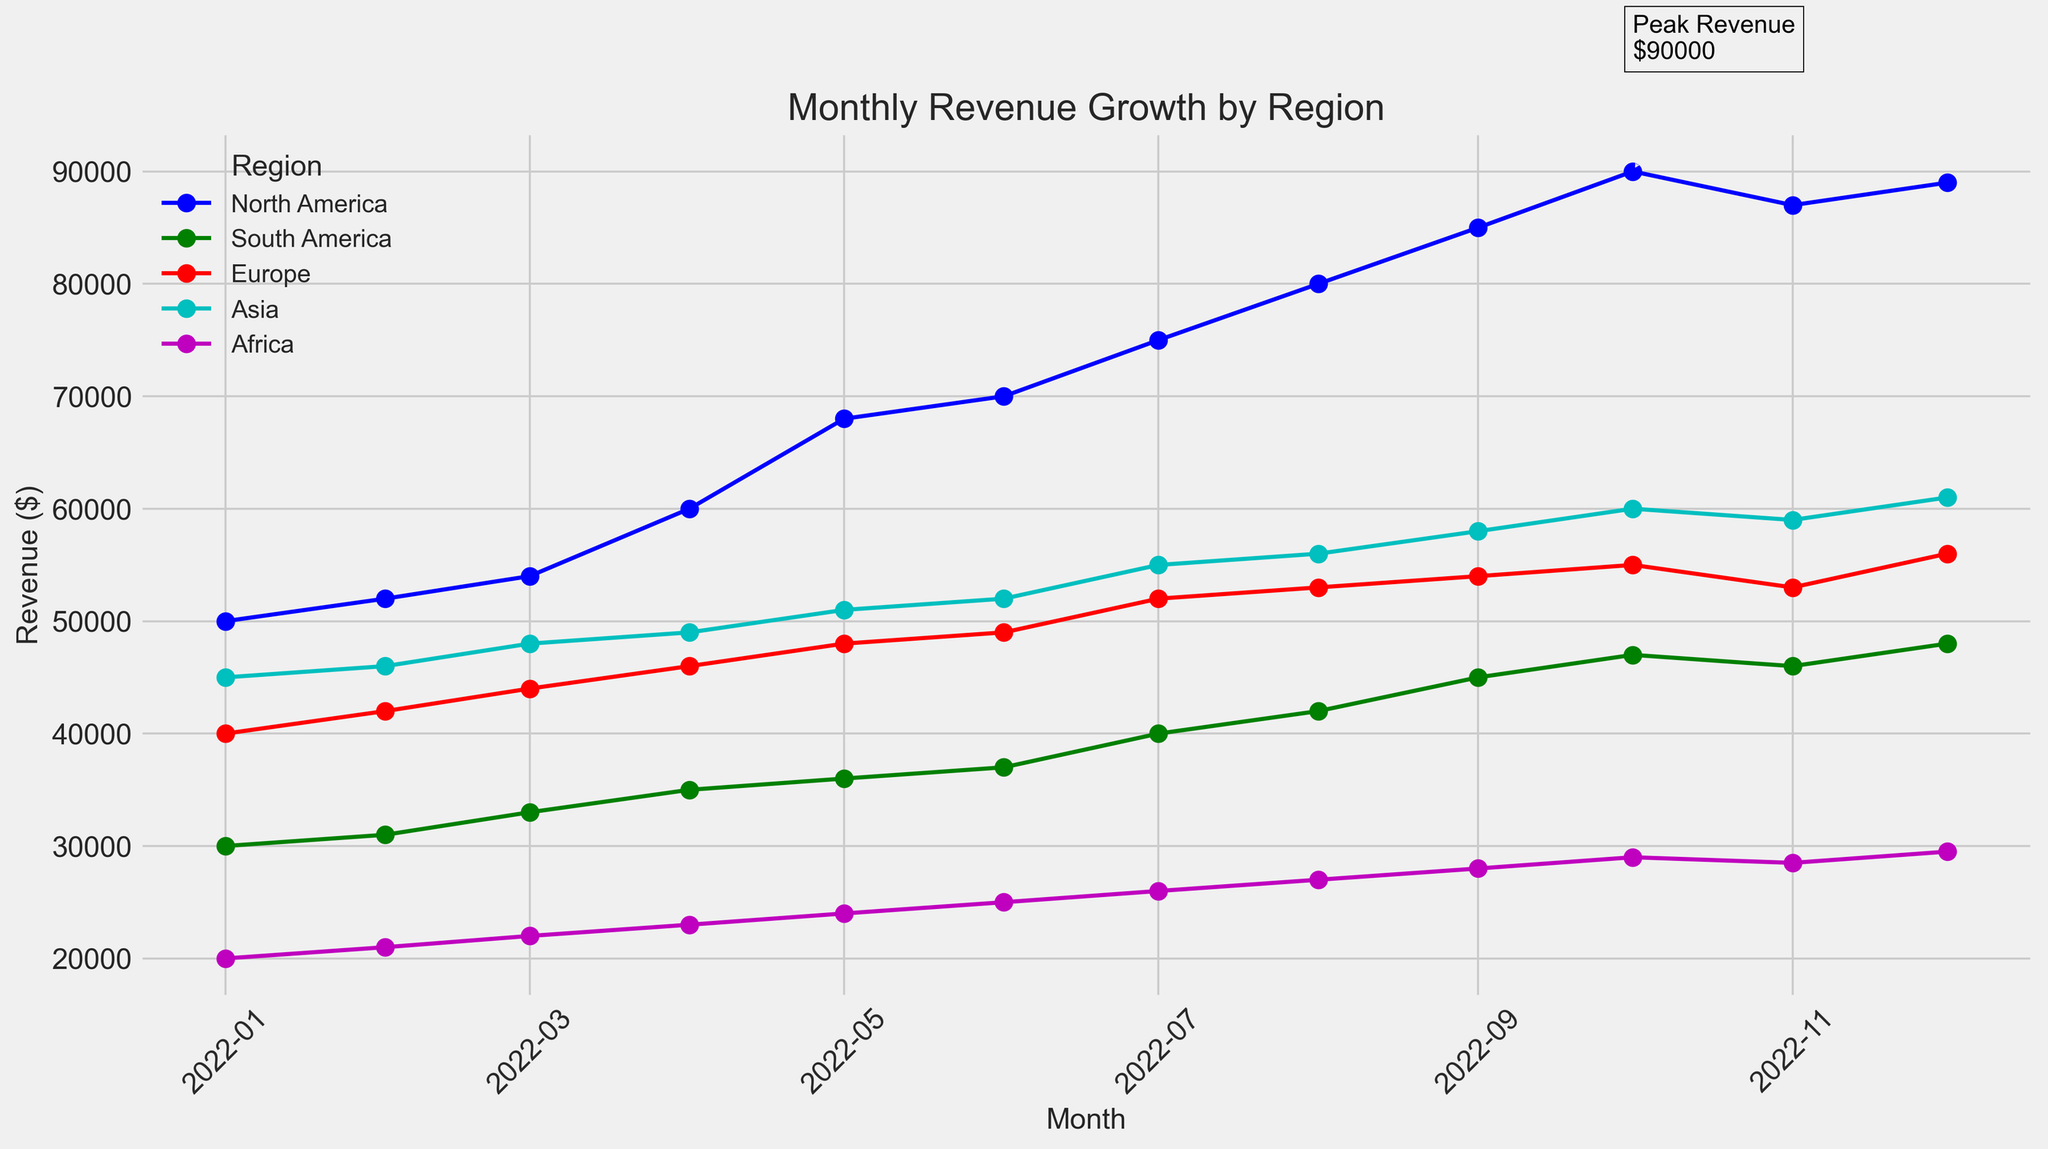Which region experienced the highest peak revenue, and in what month did it occur? The annotation on the chart indicates the peak revenue instance. By identifying this annotation, we can see that North America had the highest peak revenue, and it occurred in October 2022.
Answer: North America, October 2022 How does the revenue growth trend for North America compare to Europe over the year? Observing the slopes of the lines for North America and Europe, the North American revenue increases more steeply than Europe’s. North America had a consistent increase with a sharp rise around mid-year, while Europe’s growth is more gradual and steadier.
Answer: North America grew faster What was the peak revenue for each region? By identifying the highest points on each line, North America's peak was $90,000; South America's peak was $48,000; Europe's peak was $56,000; Asia's peak was $61,000; and Africa's peak was $29,500.
Answer: North America: $90,000, South America: $48,000, Europe: $56,000, Asia: $61,000, Africa: $29,500 Which regions experienced a decline in revenue in November 2022? Looking for revenue drops, North America and Asia experienced declines, where North America's revenue dropped from $90,000 to $87,000, and Asia’s revenue dropped from $60,000 to $59,000.
Answer: North America and Asia In which month did the revenue for South America first exceed $40,000? Following South America's trend line, the revenue first exceeds $40,000 in July 2022, where it reaches $40,000.
Answer: July 2022 How much did the revenue for North America increase from January to October 2022? The revenue for North America in January 2022 was $50,000, and in October 2022, it was $90,000. The increase is calculated as $90,000 - $50,000 = $40,000.
Answer: $40,000 Between March and August 2022, which region had the highest average revenue? Summing the revenues for each region from March to August 2022 and then finding the average: North America is ($54,000 + $60,000 + $68,000 + $70,000 + $75,000 + $80,000) / 6 = $67,833.33, South America is ($33,000 + $35,000 + $36,000 + $37,000 + $40,000 + $42,000) / 6 = $37,166.67, Europe is ($44,000 + $46,000 + $48,000 + $49,000 + $52,000 + $53,000) / 6 = $48,666.67, Asia is ($48,000 + $49,000 + $51,000 + $52,000 + $55,000 + $56,000) / 6 = $51,833.33, and Africa is ($22,000 + $23,000 + $24,000 + $25,000 + $26,000 + $27,000) / 6 = $24,500. North America had the highest average revenue.
Answer: North America What was the revenue for Europe in June 2022, and how did it change in the following month? Europe's revenue in June 2022 was $49,000. In July 2022, it increased to $52,000, resulting in a change of $3,000.
Answer: June: $49,000, Change: $3,000 Compare the revenue trend of Africa and South America. Which region experienced a more stable growth? Africa's revenue growth is nearly linear and steady, consistently increasing by about $1,000 each month, while South America shows more variability with sharper increases around mid-year. Thus, Africa experienced more stable growth.
Answer: Africa What was the minimum revenue for Asia in 2022? Scanning through the chart for Asia's revenue, the lowest value occurs in January 2022, at $45,000.
Answer: $45,000 